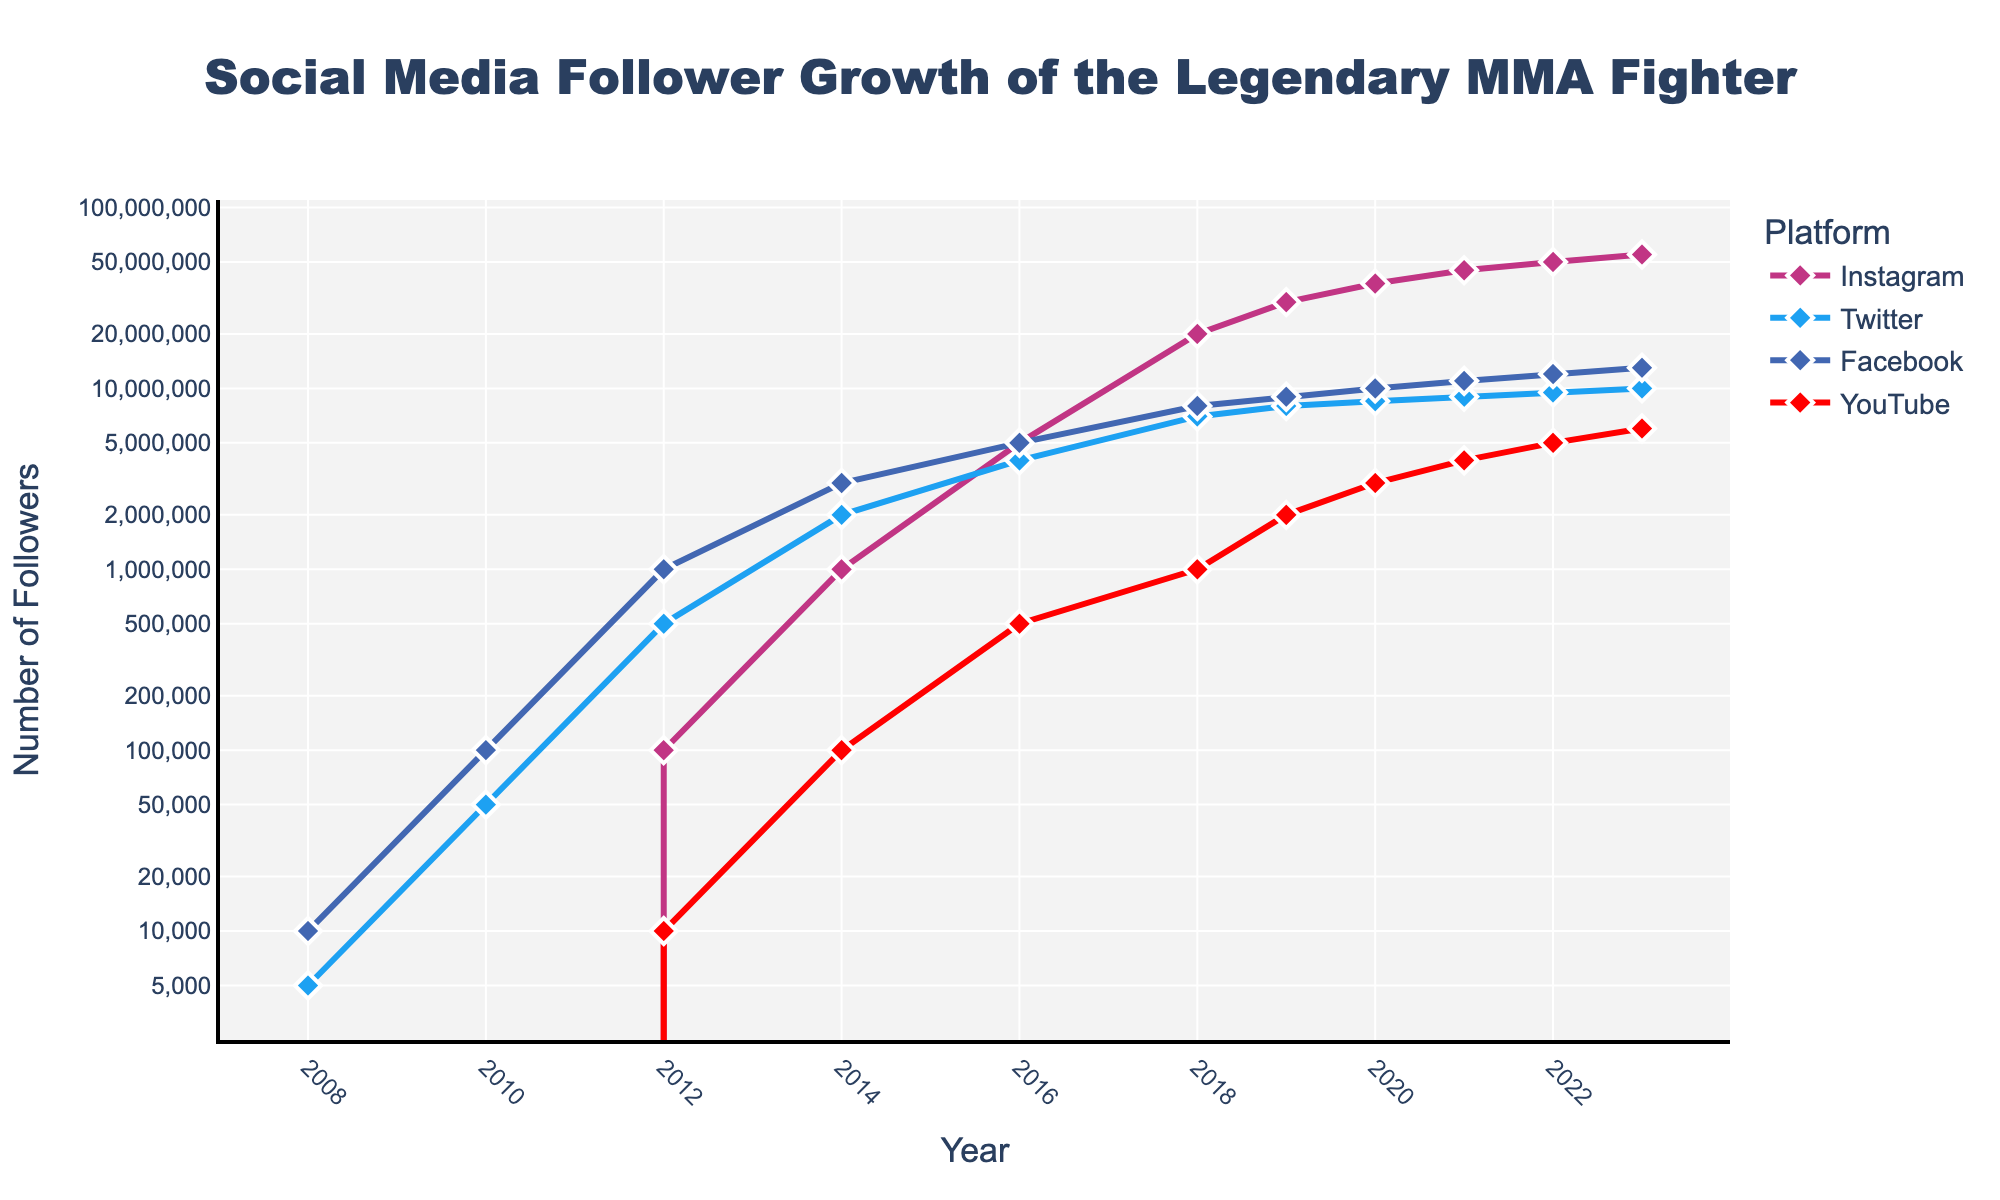Which platform had the highest follower growth from 2018 to 2019? To find the platform with the highest growth, we subtract the 2018 follower count from the 2019 follower count for each platform and compare the results: Instagram (30M - 20M = 10M), Twitter (8M - 7M = 1M), Facebook (9M - 8M = 1M), YouTube (2M - 1M = 1M). Instagram has the highest growth.
Answer: Instagram How many followers did the athlete have on Instagram in 2012 compared to YouTube in 2023? To answer this, we look at the follower counts for Instagram in 2012 (100,000) and YouTube in 2023 (6,000,000) and compare them.
Answer: Instagram: 100,000, YouTube: 6,000,000 Which year marks the first appearance of YouTube followers on the chart? This can be identified by finding the earliest year that shows a non-zero follower count for YouTube, which is in 2012.
Answer: 2012 What is the total follower count across all platforms in 2020? To find the total, we sum the follower counts for each platform in 2020: Instagram (38M), Twitter (8.5M), Facebook (10M), YouTube (3M). Summing these gives 38M + 8.5M + 10M + 3M = 59.5M.
Answer: 59.5M Between 2016 and 2018, which platform experienced the most significant percentage increase? First, calculate the percentage increase for each platform. Instagram: ((20M - 5M) / 5M) * 100 = 300%, Twitter: ((7M - 4M) / 4M) * 100 = 75%, Facebook: ((8M - 5M) / 5M) * 100 = 60%, YouTube: ((1M - 0.5M) / 0.5M) * 100 = 100%. Instagram experienced the highest percentage increase.
Answer: Instagram Which platform maintained a consistently upward trend throughout all the years? Reviewing the chart, each platform shows a continuous increase in followers every year, thus all platforms have a consistently upward trend.
Answer: Instagram, Twitter, Facebook, YouTube What is the difference in the number of followers on Facebook between 2014 and 2023? To find this, subtract the 2014 follower count from the 2023 follower count for Facebook: 13M - 3M = 10M.
Answer: 10M Which year did Instagram followers first surpass 30 million? By reviewing the data, we can observe that Instagram followers first surpassed 30 million in 2019.
Answer: 2019 Compare the follower growth trends of Instagram and Twitter from 2016 to 2023. From 2016 to 2023, Instagram's followers grew from 5 million to 55 million. Twitter's followers grew from 4 million to 10 million. Clearly, Instagram's trend is sharply upward while Twitter's upward trend is comparatively moderate.
Answer: Instagram's trend is sharper 